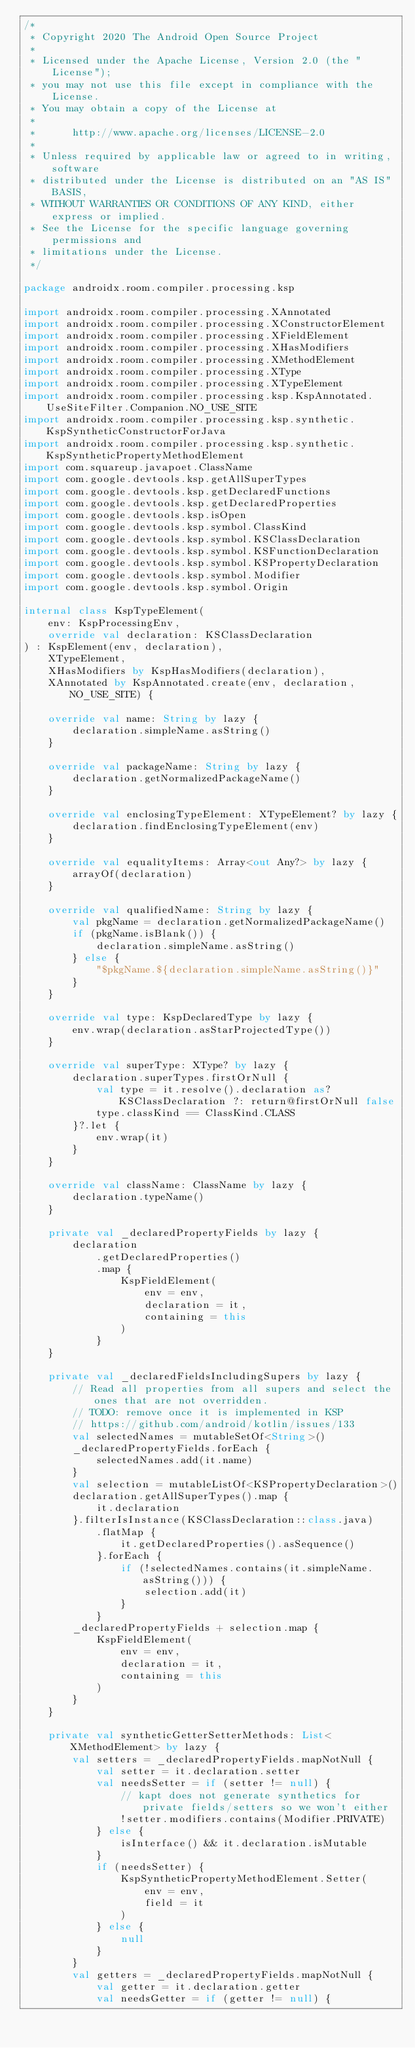<code> <loc_0><loc_0><loc_500><loc_500><_Kotlin_>/*
 * Copyright 2020 The Android Open Source Project
 *
 * Licensed under the Apache License, Version 2.0 (the "License");
 * you may not use this file except in compliance with the License.
 * You may obtain a copy of the License at
 *
 *      http://www.apache.org/licenses/LICENSE-2.0
 *
 * Unless required by applicable law or agreed to in writing, software
 * distributed under the License is distributed on an "AS IS" BASIS,
 * WITHOUT WARRANTIES OR CONDITIONS OF ANY KIND, either express or implied.
 * See the License for the specific language governing permissions and
 * limitations under the License.
 */

package androidx.room.compiler.processing.ksp

import androidx.room.compiler.processing.XAnnotated
import androidx.room.compiler.processing.XConstructorElement
import androidx.room.compiler.processing.XFieldElement
import androidx.room.compiler.processing.XHasModifiers
import androidx.room.compiler.processing.XMethodElement
import androidx.room.compiler.processing.XType
import androidx.room.compiler.processing.XTypeElement
import androidx.room.compiler.processing.ksp.KspAnnotated.UseSiteFilter.Companion.NO_USE_SITE
import androidx.room.compiler.processing.ksp.synthetic.KspSyntheticConstructorForJava
import androidx.room.compiler.processing.ksp.synthetic.KspSyntheticPropertyMethodElement
import com.squareup.javapoet.ClassName
import com.google.devtools.ksp.getAllSuperTypes
import com.google.devtools.ksp.getDeclaredFunctions
import com.google.devtools.ksp.getDeclaredProperties
import com.google.devtools.ksp.isOpen
import com.google.devtools.ksp.symbol.ClassKind
import com.google.devtools.ksp.symbol.KSClassDeclaration
import com.google.devtools.ksp.symbol.KSFunctionDeclaration
import com.google.devtools.ksp.symbol.KSPropertyDeclaration
import com.google.devtools.ksp.symbol.Modifier
import com.google.devtools.ksp.symbol.Origin

internal class KspTypeElement(
    env: KspProcessingEnv,
    override val declaration: KSClassDeclaration
) : KspElement(env, declaration),
    XTypeElement,
    XHasModifiers by KspHasModifiers(declaration),
    XAnnotated by KspAnnotated.create(env, declaration, NO_USE_SITE) {

    override val name: String by lazy {
        declaration.simpleName.asString()
    }

    override val packageName: String by lazy {
        declaration.getNormalizedPackageName()
    }

    override val enclosingTypeElement: XTypeElement? by lazy {
        declaration.findEnclosingTypeElement(env)
    }

    override val equalityItems: Array<out Any?> by lazy {
        arrayOf(declaration)
    }

    override val qualifiedName: String by lazy {
        val pkgName = declaration.getNormalizedPackageName()
        if (pkgName.isBlank()) {
            declaration.simpleName.asString()
        } else {
            "$pkgName.${declaration.simpleName.asString()}"
        }
    }

    override val type: KspDeclaredType by lazy {
        env.wrap(declaration.asStarProjectedType())
    }

    override val superType: XType? by lazy {
        declaration.superTypes.firstOrNull {
            val type = it.resolve().declaration as? KSClassDeclaration ?: return@firstOrNull false
            type.classKind == ClassKind.CLASS
        }?.let {
            env.wrap(it)
        }
    }

    override val className: ClassName by lazy {
        declaration.typeName()
    }

    private val _declaredPropertyFields by lazy {
        declaration
            .getDeclaredProperties()
            .map {
                KspFieldElement(
                    env = env,
                    declaration = it,
                    containing = this
                )
            }
    }

    private val _declaredFieldsIncludingSupers by lazy {
        // Read all properties from all supers and select the ones that are not overridden.
        // TODO: remove once it is implemented in KSP
        // https://github.com/android/kotlin/issues/133
        val selectedNames = mutableSetOf<String>()
        _declaredPropertyFields.forEach {
            selectedNames.add(it.name)
        }
        val selection = mutableListOf<KSPropertyDeclaration>()
        declaration.getAllSuperTypes().map {
            it.declaration
        }.filterIsInstance(KSClassDeclaration::class.java)
            .flatMap {
                it.getDeclaredProperties().asSequence()
            }.forEach {
                if (!selectedNames.contains(it.simpleName.asString())) {
                    selection.add(it)
                }
            }
        _declaredPropertyFields + selection.map {
            KspFieldElement(
                env = env,
                declaration = it,
                containing = this
            )
        }
    }

    private val syntheticGetterSetterMethods: List<XMethodElement> by lazy {
        val setters = _declaredPropertyFields.mapNotNull {
            val setter = it.declaration.setter
            val needsSetter = if (setter != null) {
                // kapt does not generate synthetics for private fields/setters so we won't either
                !setter.modifiers.contains(Modifier.PRIVATE)
            } else {
                isInterface() && it.declaration.isMutable
            }
            if (needsSetter) {
                KspSyntheticPropertyMethodElement.Setter(
                    env = env,
                    field = it
                )
            } else {
                null
            }
        }
        val getters = _declaredPropertyFields.mapNotNull {
            val getter = it.declaration.getter
            val needsGetter = if (getter != null) {</code> 